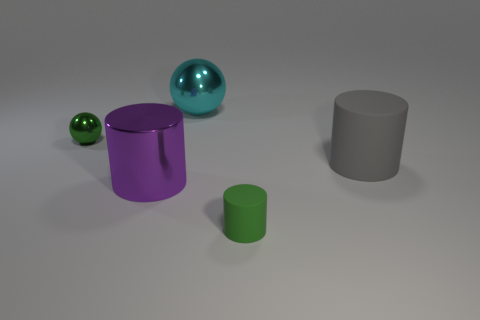There is a green thing that is right of the tiny shiny thing; what number of large gray matte cylinders are in front of it? In the image, directly in front of the green object to its left, there are no large gray matte cylinders present. 